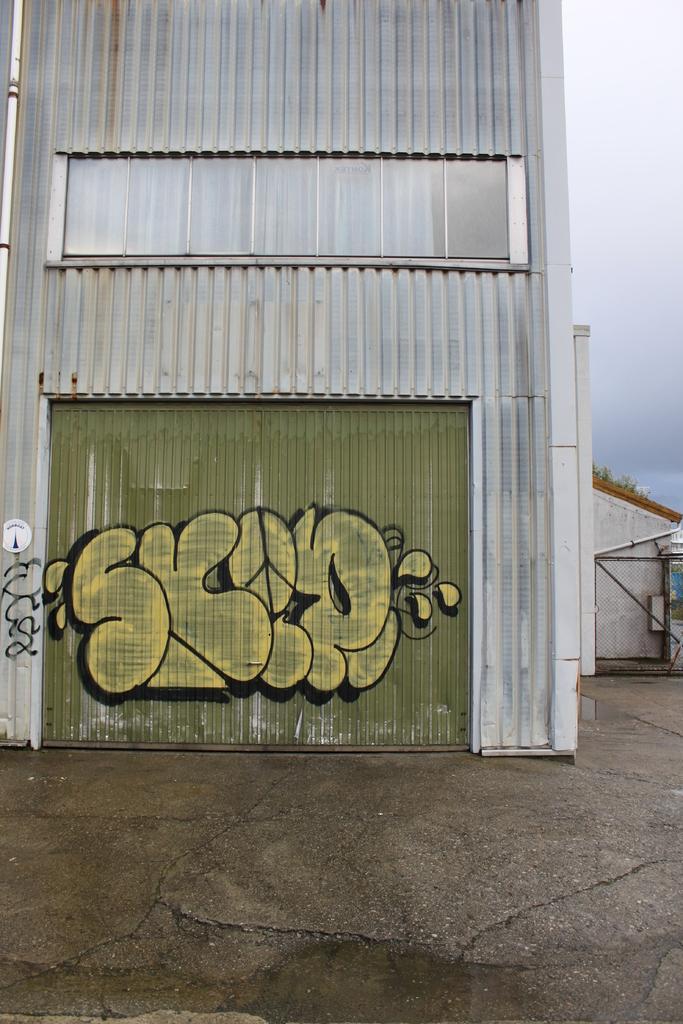Please provide a concise description of this image. In this image I can see building. Here I can see something painted on the wall. In the background I can see the sky. 